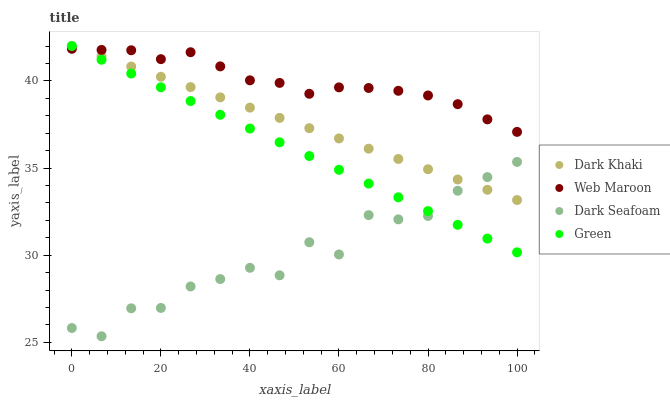Does Dark Seafoam have the minimum area under the curve?
Answer yes or no. Yes. Does Web Maroon have the maximum area under the curve?
Answer yes or no. Yes. Does Green have the minimum area under the curve?
Answer yes or no. No. Does Green have the maximum area under the curve?
Answer yes or no. No. Is Green the smoothest?
Answer yes or no. Yes. Is Dark Seafoam the roughest?
Answer yes or no. Yes. Is Dark Seafoam the smoothest?
Answer yes or no. No. Is Green the roughest?
Answer yes or no. No. Does Dark Seafoam have the lowest value?
Answer yes or no. Yes. Does Green have the lowest value?
Answer yes or no. No. Does Green have the highest value?
Answer yes or no. Yes. Does Dark Seafoam have the highest value?
Answer yes or no. No. Is Dark Seafoam less than Web Maroon?
Answer yes or no. Yes. Is Web Maroon greater than Dark Seafoam?
Answer yes or no. Yes. Does Dark Khaki intersect Green?
Answer yes or no. Yes. Is Dark Khaki less than Green?
Answer yes or no. No. Is Dark Khaki greater than Green?
Answer yes or no. No. Does Dark Seafoam intersect Web Maroon?
Answer yes or no. No. 